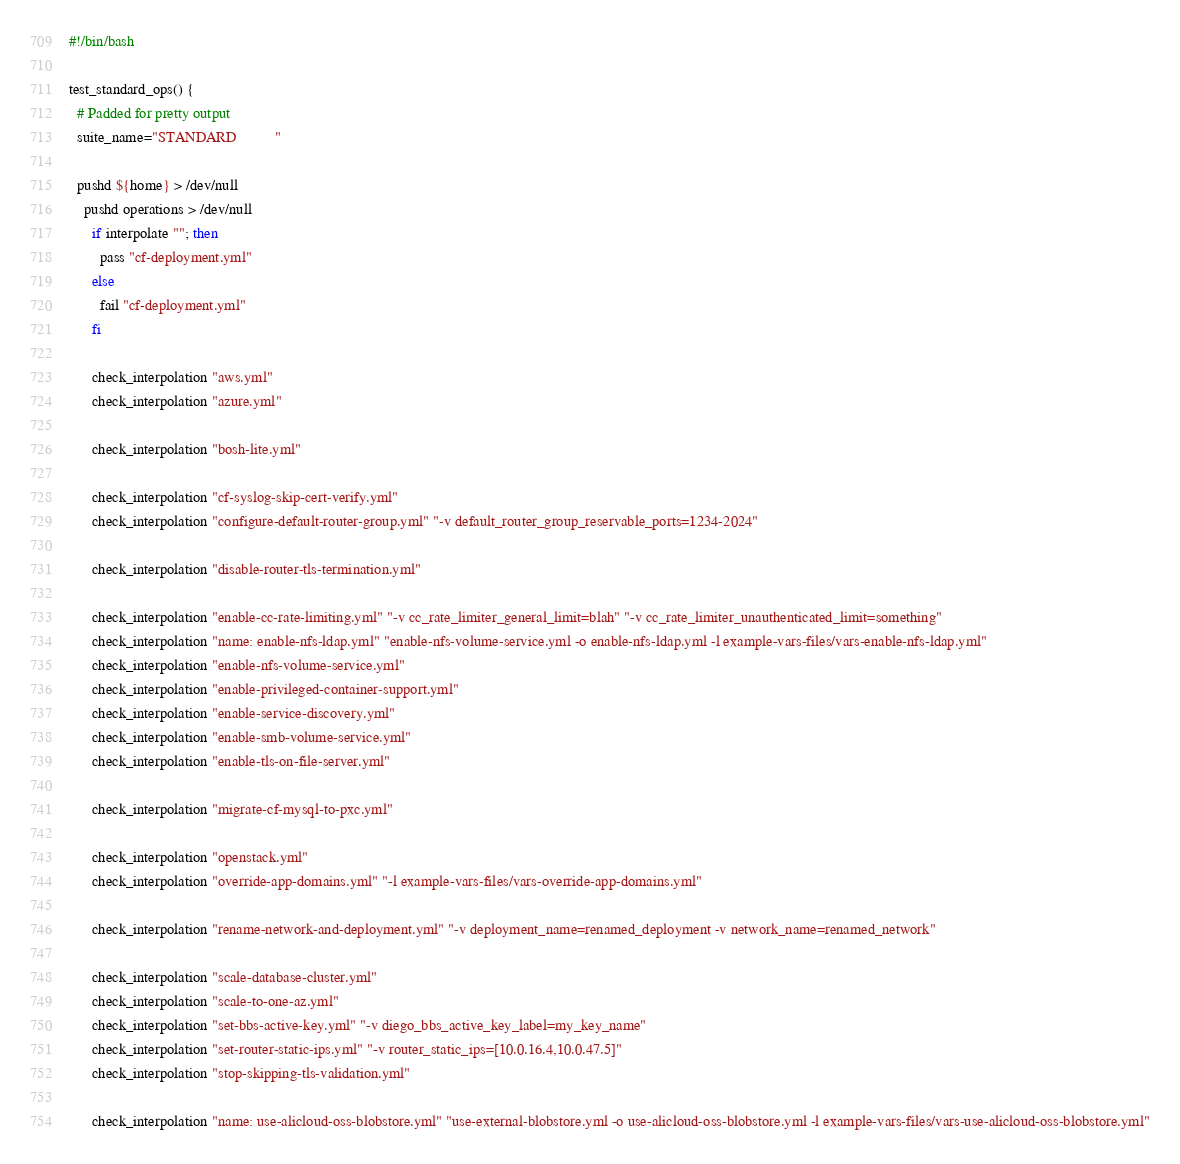<code> <loc_0><loc_0><loc_500><loc_500><_Bash_>#!/bin/bash

test_standard_ops() {
  # Padded for pretty output
  suite_name="STANDARD          "

  pushd ${home} > /dev/null
    pushd operations > /dev/null
      if interpolate ""; then
        pass "cf-deployment.yml"
      else
        fail "cf-deployment.yml"
      fi

      check_interpolation "aws.yml"
      check_interpolation "azure.yml"

      check_interpolation "bosh-lite.yml"

      check_interpolation "cf-syslog-skip-cert-verify.yml"
      check_interpolation "configure-default-router-group.yml" "-v default_router_group_reservable_ports=1234-2024"

      check_interpolation "disable-router-tls-termination.yml"

      check_interpolation "enable-cc-rate-limiting.yml" "-v cc_rate_limiter_general_limit=blah" "-v cc_rate_limiter_unauthenticated_limit=something"
      check_interpolation "name: enable-nfs-ldap.yml" "enable-nfs-volume-service.yml -o enable-nfs-ldap.yml -l example-vars-files/vars-enable-nfs-ldap.yml"
      check_interpolation "enable-nfs-volume-service.yml"
      check_interpolation "enable-privileged-container-support.yml"
      check_interpolation "enable-service-discovery.yml"
      check_interpolation "enable-smb-volume-service.yml"
      check_interpolation "enable-tls-on-file-server.yml"

      check_interpolation "migrate-cf-mysql-to-pxc.yml"

      check_interpolation "openstack.yml"
      check_interpolation "override-app-domains.yml" "-l example-vars-files/vars-override-app-domains.yml"

      check_interpolation "rename-network-and-deployment.yml" "-v deployment_name=renamed_deployment -v network_name=renamed_network"

      check_interpolation "scale-database-cluster.yml"
      check_interpolation "scale-to-one-az.yml"
      check_interpolation "set-bbs-active-key.yml" "-v diego_bbs_active_key_label=my_key_name"
      check_interpolation "set-router-static-ips.yml" "-v router_static_ips=[10.0.16.4,10.0.47.5]"
      check_interpolation "stop-skipping-tls-validation.yml"

      check_interpolation "name: use-alicloud-oss-blobstore.yml" "use-external-blobstore.yml -o use-alicloud-oss-blobstore.yml -l example-vars-files/vars-use-alicloud-oss-blobstore.yml"</code> 